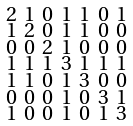Convert formula to latex. <formula><loc_0><loc_0><loc_500><loc_500>\begin{smallmatrix} 2 & 1 & 0 & 1 & 1 & 0 & 1 \\ 1 & 2 & 0 & 1 & 1 & 0 & 0 \\ 0 & 0 & 2 & 1 & 0 & 0 & 0 \\ 1 & 1 & 1 & 3 & 1 & 1 & 1 \\ 1 & 1 & 0 & 1 & 3 & 0 & 0 \\ 0 & 0 & 0 & 1 & 0 & 3 & 1 \\ 1 & 0 & 0 & 1 & 0 & 1 & 3 \end{smallmatrix}</formula> 